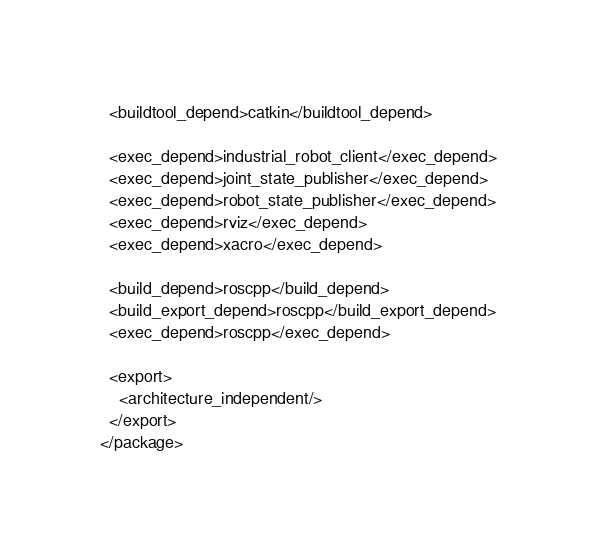Convert code to text. <code><loc_0><loc_0><loc_500><loc_500><_XML_>
  <buildtool_depend>catkin</buildtool_depend>

  <exec_depend>industrial_robot_client</exec_depend>
  <exec_depend>joint_state_publisher</exec_depend>
  <exec_depend>robot_state_publisher</exec_depend>
  <exec_depend>rviz</exec_depend>
  <exec_depend>xacro</exec_depend>
  
  <build_depend>roscpp</build_depend>
  <build_export_depend>roscpp</build_export_depend>
  <exec_depend>roscpp</exec_depend>

  <export>
    <architecture_independent/>
  </export>
</package>
</code> 